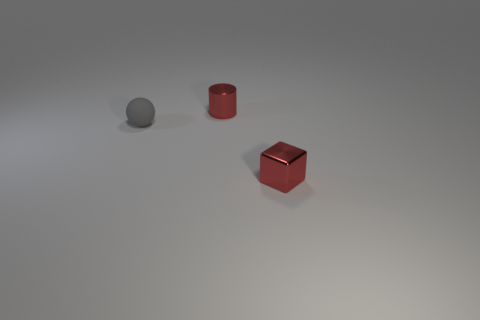What lighting conditions are present in the image? The lighting in the image appears to be soft and diffuse, with a gentle overhead light that creates subtle shadows under each object. This soft lighting helps to enhance the textural details and differences among the objects without causing harsh reflections. Does the lighting affect the perception of the objects' colors? Yes, the soft and diffuse lighting can slightly alter the perception of the objects' colors by softening their intensity. This could make the colors appear less vibrant but more consistent across the image, providing a true representation of their natural hues under neutral lighting conditions. 